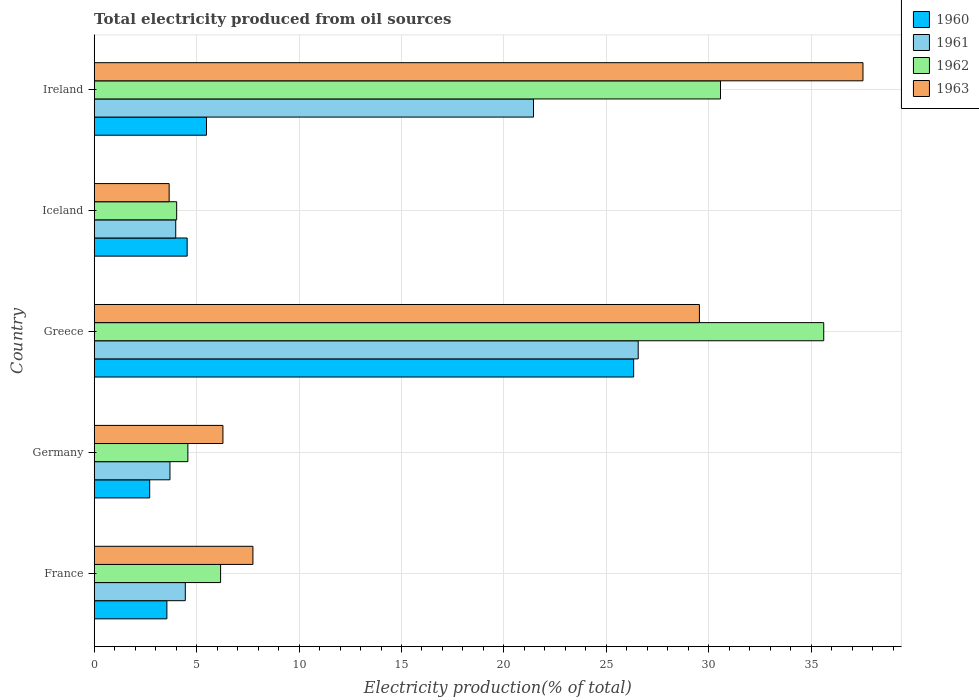How many bars are there on the 4th tick from the top?
Provide a short and direct response. 4. In how many cases, is the number of bars for a given country not equal to the number of legend labels?
Make the answer very short. 0. What is the total electricity produced in 1960 in France?
Provide a succinct answer. 3.55. Across all countries, what is the maximum total electricity produced in 1962?
Provide a succinct answer. 35.61. Across all countries, what is the minimum total electricity produced in 1961?
Offer a terse response. 3.7. In which country was the total electricity produced in 1962 minimum?
Ensure brevity in your answer.  Iceland. What is the total total electricity produced in 1963 in the graph?
Offer a very short reply. 84.76. What is the difference between the total electricity produced in 1962 in Germany and that in Ireland?
Your answer should be compact. -26. What is the difference between the total electricity produced in 1961 in Ireland and the total electricity produced in 1960 in Germany?
Offer a very short reply. 18.73. What is the average total electricity produced in 1963 per country?
Your response must be concise. 16.95. What is the difference between the total electricity produced in 1963 and total electricity produced in 1962 in Ireland?
Provide a succinct answer. 6.95. In how many countries, is the total electricity produced in 1962 greater than 2 %?
Provide a short and direct response. 5. What is the ratio of the total electricity produced in 1962 in France to that in Greece?
Your answer should be very brief. 0.17. Is the total electricity produced in 1960 in Iceland less than that in Ireland?
Keep it short and to the point. Yes. Is the difference between the total electricity produced in 1963 in Greece and Ireland greater than the difference between the total electricity produced in 1962 in Greece and Ireland?
Offer a very short reply. No. What is the difference between the highest and the second highest total electricity produced in 1961?
Your answer should be compact. 5.11. What is the difference between the highest and the lowest total electricity produced in 1963?
Offer a terse response. 33.87. In how many countries, is the total electricity produced in 1963 greater than the average total electricity produced in 1963 taken over all countries?
Keep it short and to the point. 2. Is it the case that in every country, the sum of the total electricity produced in 1960 and total electricity produced in 1962 is greater than the sum of total electricity produced in 1961 and total electricity produced in 1963?
Your answer should be very brief. No. What does the 1st bar from the top in Germany represents?
Give a very brief answer. 1963. Is it the case that in every country, the sum of the total electricity produced in 1963 and total electricity produced in 1960 is greater than the total electricity produced in 1961?
Offer a very short reply. Yes. How many bars are there?
Your response must be concise. 20. What is the difference between two consecutive major ticks on the X-axis?
Your answer should be very brief. 5. Are the values on the major ticks of X-axis written in scientific E-notation?
Your answer should be very brief. No. Does the graph contain any zero values?
Offer a very short reply. No. Does the graph contain grids?
Make the answer very short. Yes. Where does the legend appear in the graph?
Your answer should be compact. Top right. How many legend labels are there?
Offer a very short reply. 4. How are the legend labels stacked?
Your answer should be compact. Vertical. What is the title of the graph?
Your answer should be very brief. Total electricity produced from oil sources. What is the label or title of the Y-axis?
Provide a succinct answer. Country. What is the Electricity production(% of total) of 1960 in France?
Your answer should be very brief. 3.55. What is the Electricity production(% of total) of 1961 in France?
Keep it short and to the point. 4.45. What is the Electricity production(% of total) of 1962 in France?
Your response must be concise. 6.17. What is the Electricity production(% of total) of 1963 in France?
Keep it short and to the point. 7.75. What is the Electricity production(% of total) of 1960 in Germany?
Give a very brief answer. 2.71. What is the Electricity production(% of total) in 1961 in Germany?
Keep it short and to the point. 3.7. What is the Electricity production(% of total) in 1962 in Germany?
Your response must be concise. 4.57. What is the Electricity production(% of total) of 1963 in Germany?
Make the answer very short. 6.28. What is the Electricity production(% of total) of 1960 in Greece?
Your response must be concise. 26.33. What is the Electricity production(% of total) in 1961 in Greece?
Ensure brevity in your answer.  26.55. What is the Electricity production(% of total) of 1962 in Greece?
Make the answer very short. 35.61. What is the Electricity production(% of total) in 1963 in Greece?
Provide a succinct answer. 29.54. What is the Electricity production(% of total) of 1960 in Iceland?
Your answer should be very brief. 4.54. What is the Electricity production(% of total) in 1961 in Iceland?
Your answer should be compact. 3.98. What is the Electricity production(% of total) of 1962 in Iceland?
Your answer should be very brief. 4.03. What is the Electricity production(% of total) of 1963 in Iceland?
Your answer should be compact. 3.66. What is the Electricity production(% of total) of 1960 in Ireland?
Your answer should be compact. 5.48. What is the Electricity production(% of total) in 1961 in Ireland?
Give a very brief answer. 21.44. What is the Electricity production(% of total) of 1962 in Ireland?
Your response must be concise. 30.57. What is the Electricity production(% of total) of 1963 in Ireland?
Provide a short and direct response. 37.53. Across all countries, what is the maximum Electricity production(% of total) in 1960?
Your answer should be very brief. 26.33. Across all countries, what is the maximum Electricity production(% of total) in 1961?
Your response must be concise. 26.55. Across all countries, what is the maximum Electricity production(% of total) in 1962?
Provide a short and direct response. 35.61. Across all countries, what is the maximum Electricity production(% of total) in 1963?
Your answer should be very brief. 37.53. Across all countries, what is the minimum Electricity production(% of total) in 1960?
Provide a short and direct response. 2.71. Across all countries, what is the minimum Electricity production(% of total) of 1961?
Provide a short and direct response. 3.7. Across all countries, what is the minimum Electricity production(% of total) of 1962?
Your answer should be compact. 4.03. Across all countries, what is the minimum Electricity production(% of total) in 1963?
Your answer should be very brief. 3.66. What is the total Electricity production(% of total) of 1960 in the graph?
Provide a short and direct response. 42.61. What is the total Electricity production(% of total) of 1961 in the graph?
Keep it short and to the point. 60.12. What is the total Electricity production(% of total) of 1962 in the graph?
Offer a terse response. 80.95. What is the total Electricity production(% of total) of 1963 in the graph?
Offer a terse response. 84.76. What is the difference between the Electricity production(% of total) in 1960 in France and that in Germany?
Provide a short and direct response. 0.84. What is the difference between the Electricity production(% of total) of 1961 in France and that in Germany?
Give a very brief answer. 0.75. What is the difference between the Electricity production(% of total) in 1962 in France and that in Germany?
Your answer should be compact. 1.6. What is the difference between the Electricity production(% of total) in 1963 in France and that in Germany?
Your response must be concise. 1.46. What is the difference between the Electricity production(% of total) of 1960 in France and that in Greece?
Ensure brevity in your answer.  -22.78. What is the difference between the Electricity production(% of total) in 1961 in France and that in Greece?
Your response must be concise. -22.11. What is the difference between the Electricity production(% of total) in 1962 in France and that in Greece?
Offer a very short reply. -29.44. What is the difference between the Electricity production(% of total) of 1963 in France and that in Greece?
Make the answer very short. -21.79. What is the difference between the Electricity production(% of total) in 1960 in France and that in Iceland?
Your answer should be compact. -0.99. What is the difference between the Electricity production(% of total) of 1961 in France and that in Iceland?
Ensure brevity in your answer.  0.47. What is the difference between the Electricity production(% of total) of 1962 in France and that in Iceland?
Ensure brevity in your answer.  2.14. What is the difference between the Electricity production(% of total) in 1963 in France and that in Iceland?
Provide a short and direct response. 4.09. What is the difference between the Electricity production(% of total) in 1960 in France and that in Ireland?
Your answer should be very brief. -1.93. What is the difference between the Electricity production(% of total) of 1961 in France and that in Ireland?
Give a very brief answer. -17. What is the difference between the Electricity production(% of total) of 1962 in France and that in Ireland?
Make the answer very short. -24.4. What is the difference between the Electricity production(% of total) in 1963 in France and that in Ireland?
Your answer should be very brief. -29.78. What is the difference between the Electricity production(% of total) in 1960 in Germany and that in Greece?
Your response must be concise. -23.62. What is the difference between the Electricity production(% of total) of 1961 in Germany and that in Greece?
Your response must be concise. -22.86. What is the difference between the Electricity production(% of total) in 1962 in Germany and that in Greece?
Your answer should be very brief. -31.04. What is the difference between the Electricity production(% of total) in 1963 in Germany and that in Greece?
Offer a very short reply. -23.26. What is the difference between the Electricity production(% of total) in 1960 in Germany and that in Iceland?
Give a very brief answer. -1.83. What is the difference between the Electricity production(% of total) in 1961 in Germany and that in Iceland?
Make the answer very short. -0.28. What is the difference between the Electricity production(% of total) of 1962 in Germany and that in Iceland?
Provide a short and direct response. 0.55. What is the difference between the Electricity production(% of total) in 1963 in Germany and that in Iceland?
Make the answer very short. 2.63. What is the difference between the Electricity production(% of total) of 1960 in Germany and that in Ireland?
Give a very brief answer. -2.77. What is the difference between the Electricity production(% of total) in 1961 in Germany and that in Ireland?
Your response must be concise. -17.75. What is the difference between the Electricity production(% of total) in 1962 in Germany and that in Ireland?
Ensure brevity in your answer.  -26. What is the difference between the Electricity production(% of total) of 1963 in Germany and that in Ireland?
Your response must be concise. -31.24. What is the difference between the Electricity production(% of total) in 1960 in Greece and that in Iceland?
Make the answer very short. 21.79. What is the difference between the Electricity production(% of total) of 1961 in Greece and that in Iceland?
Provide a short and direct response. 22.57. What is the difference between the Electricity production(% of total) in 1962 in Greece and that in Iceland?
Your response must be concise. 31.58. What is the difference between the Electricity production(% of total) of 1963 in Greece and that in Iceland?
Your answer should be compact. 25.88. What is the difference between the Electricity production(% of total) of 1960 in Greece and that in Ireland?
Offer a terse response. 20.85. What is the difference between the Electricity production(% of total) in 1961 in Greece and that in Ireland?
Your answer should be very brief. 5.11. What is the difference between the Electricity production(% of total) of 1962 in Greece and that in Ireland?
Give a very brief answer. 5.04. What is the difference between the Electricity production(% of total) in 1963 in Greece and that in Ireland?
Offer a very short reply. -7.99. What is the difference between the Electricity production(% of total) of 1960 in Iceland and that in Ireland?
Your answer should be compact. -0.94. What is the difference between the Electricity production(% of total) of 1961 in Iceland and that in Ireland?
Your response must be concise. -17.46. What is the difference between the Electricity production(% of total) in 1962 in Iceland and that in Ireland?
Offer a very short reply. -26.55. What is the difference between the Electricity production(% of total) of 1963 in Iceland and that in Ireland?
Your answer should be very brief. -33.87. What is the difference between the Electricity production(% of total) in 1960 in France and the Electricity production(% of total) in 1961 in Germany?
Offer a terse response. -0.15. What is the difference between the Electricity production(% of total) of 1960 in France and the Electricity production(% of total) of 1962 in Germany?
Provide a short and direct response. -1.02. What is the difference between the Electricity production(% of total) of 1960 in France and the Electricity production(% of total) of 1963 in Germany?
Provide a short and direct response. -2.74. What is the difference between the Electricity production(% of total) in 1961 in France and the Electricity production(% of total) in 1962 in Germany?
Your answer should be very brief. -0.13. What is the difference between the Electricity production(% of total) in 1961 in France and the Electricity production(% of total) in 1963 in Germany?
Make the answer very short. -1.84. What is the difference between the Electricity production(% of total) in 1962 in France and the Electricity production(% of total) in 1963 in Germany?
Keep it short and to the point. -0.11. What is the difference between the Electricity production(% of total) in 1960 in France and the Electricity production(% of total) in 1961 in Greece?
Provide a succinct answer. -23.01. What is the difference between the Electricity production(% of total) of 1960 in France and the Electricity production(% of total) of 1962 in Greece?
Offer a very short reply. -32.06. What is the difference between the Electricity production(% of total) of 1960 in France and the Electricity production(% of total) of 1963 in Greece?
Provide a short and direct response. -25.99. What is the difference between the Electricity production(% of total) in 1961 in France and the Electricity production(% of total) in 1962 in Greece?
Provide a succinct answer. -31.16. What is the difference between the Electricity production(% of total) in 1961 in France and the Electricity production(% of total) in 1963 in Greece?
Your answer should be very brief. -25.09. What is the difference between the Electricity production(% of total) in 1962 in France and the Electricity production(% of total) in 1963 in Greece?
Offer a terse response. -23.37. What is the difference between the Electricity production(% of total) of 1960 in France and the Electricity production(% of total) of 1961 in Iceland?
Make the answer very short. -0.43. What is the difference between the Electricity production(% of total) in 1960 in France and the Electricity production(% of total) in 1962 in Iceland?
Give a very brief answer. -0.48. What is the difference between the Electricity production(% of total) in 1960 in France and the Electricity production(% of total) in 1963 in Iceland?
Provide a succinct answer. -0.11. What is the difference between the Electricity production(% of total) in 1961 in France and the Electricity production(% of total) in 1962 in Iceland?
Provide a short and direct response. 0.42. What is the difference between the Electricity production(% of total) in 1961 in France and the Electricity production(% of total) in 1963 in Iceland?
Ensure brevity in your answer.  0.79. What is the difference between the Electricity production(% of total) in 1962 in France and the Electricity production(% of total) in 1963 in Iceland?
Keep it short and to the point. 2.51. What is the difference between the Electricity production(% of total) of 1960 in France and the Electricity production(% of total) of 1961 in Ireland?
Provide a succinct answer. -17.9. What is the difference between the Electricity production(% of total) of 1960 in France and the Electricity production(% of total) of 1962 in Ireland?
Your answer should be compact. -27.02. What is the difference between the Electricity production(% of total) in 1960 in France and the Electricity production(% of total) in 1963 in Ireland?
Offer a very short reply. -33.98. What is the difference between the Electricity production(% of total) of 1961 in France and the Electricity production(% of total) of 1962 in Ireland?
Offer a very short reply. -26.12. What is the difference between the Electricity production(% of total) in 1961 in France and the Electricity production(% of total) in 1963 in Ireland?
Your answer should be very brief. -33.08. What is the difference between the Electricity production(% of total) in 1962 in France and the Electricity production(% of total) in 1963 in Ireland?
Make the answer very short. -31.36. What is the difference between the Electricity production(% of total) of 1960 in Germany and the Electricity production(% of total) of 1961 in Greece?
Your answer should be compact. -23.85. What is the difference between the Electricity production(% of total) in 1960 in Germany and the Electricity production(% of total) in 1962 in Greece?
Keep it short and to the point. -32.9. What is the difference between the Electricity production(% of total) in 1960 in Germany and the Electricity production(% of total) in 1963 in Greece?
Ensure brevity in your answer.  -26.83. What is the difference between the Electricity production(% of total) of 1961 in Germany and the Electricity production(% of total) of 1962 in Greece?
Make the answer very short. -31.91. What is the difference between the Electricity production(% of total) in 1961 in Germany and the Electricity production(% of total) in 1963 in Greece?
Your answer should be compact. -25.84. What is the difference between the Electricity production(% of total) of 1962 in Germany and the Electricity production(% of total) of 1963 in Greece?
Offer a very short reply. -24.97. What is the difference between the Electricity production(% of total) of 1960 in Germany and the Electricity production(% of total) of 1961 in Iceland?
Provide a short and direct response. -1.27. What is the difference between the Electricity production(% of total) in 1960 in Germany and the Electricity production(% of total) in 1962 in Iceland?
Give a very brief answer. -1.32. What is the difference between the Electricity production(% of total) in 1960 in Germany and the Electricity production(% of total) in 1963 in Iceland?
Make the answer very short. -0.95. What is the difference between the Electricity production(% of total) of 1961 in Germany and the Electricity production(% of total) of 1962 in Iceland?
Your answer should be very brief. -0.33. What is the difference between the Electricity production(% of total) of 1961 in Germany and the Electricity production(% of total) of 1963 in Iceland?
Offer a very short reply. 0.04. What is the difference between the Electricity production(% of total) in 1962 in Germany and the Electricity production(% of total) in 1963 in Iceland?
Your answer should be compact. 0.91. What is the difference between the Electricity production(% of total) of 1960 in Germany and the Electricity production(% of total) of 1961 in Ireland?
Provide a succinct answer. -18.73. What is the difference between the Electricity production(% of total) in 1960 in Germany and the Electricity production(% of total) in 1962 in Ireland?
Your answer should be very brief. -27.86. What is the difference between the Electricity production(% of total) in 1960 in Germany and the Electricity production(% of total) in 1963 in Ireland?
Provide a short and direct response. -34.82. What is the difference between the Electricity production(% of total) of 1961 in Germany and the Electricity production(% of total) of 1962 in Ireland?
Your response must be concise. -26.87. What is the difference between the Electricity production(% of total) of 1961 in Germany and the Electricity production(% of total) of 1963 in Ireland?
Provide a short and direct response. -33.83. What is the difference between the Electricity production(% of total) in 1962 in Germany and the Electricity production(% of total) in 1963 in Ireland?
Your response must be concise. -32.95. What is the difference between the Electricity production(% of total) of 1960 in Greece and the Electricity production(% of total) of 1961 in Iceland?
Ensure brevity in your answer.  22.35. What is the difference between the Electricity production(% of total) in 1960 in Greece and the Electricity production(% of total) in 1962 in Iceland?
Give a very brief answer. 22.31. What is the difference between the Electricity production(% of total) in 1960 in Greece and the Electricity production(% of total) in 1963 in Iceland?
Your response must be concise. 22.67. What is the difference between the Electricity production(% of total) in 1961 in Greece and the Electricity production(% of total) in 1962 in Iceland?
Provide a short and direct response. 22.53. What is the difference between the Electricity production(% of total) of 1961 in Greece and the Electricity production(% of total) of 1963 in Iceland?
Offer a terse response. 22.9. What is the difference between the Electricity production(% of total) in 1962 in Greece and the Electricity production(% of total) in 1963 in Iceland?
Offer a terse response. 31.95. What is the difference between the Electricity production(% of total) of 1960 in Greece and the Electricity production(% of total) of 1961 in Ireland?
Make the answer very short. 4.89. What is the difference between the Electricity production(% of total) of 1960 in Greece and the Electricity production(% of total) of 1962 in Ireland?
Offer a very short reply. -4.24. What is the difference between the Electricity production(% of total) in 1960 in Greece and the Electricity production(% of total) in 1963 in Ireland?
Your answer should be very brief. -11.19. What is the difference between the Electricity production(% of total) of 1961 in Greece and the Electricity production(% of total) of 1962 in Ireland?
Your answer should be very brief. -4.02. What is the difference between the Electricity production(% of total) of 1961 in Greece and the Electricity production(% of total) of 1963 in Ireland?
Your response must be concise. -10.97. What is the difference between the Electricity production(% of total) in 1962 in Greece and the Electricity production(% of total) in 1963 in Ireland?
Your answer should be compact. -1.92. What is the difference between the Electricity production(% of total) in 1960 in Iceland and the Electricity production(% of total) in 1961 in Ireland?
Provide a succinct answer. -16.91. What is the difference between the Electricity production(% of total) in 1960 in Iceland and the Electricity production(% of total) in 1962 in Ireland?
Ensure brevity in your answer.  -26.03. What is the difference between the Electricity production(% of total) in 1960 in Iceland and the Electricity production(% of total) in 1963 in Ireland?
Provide a short and direct response. -32.99. What is the difference between the Electricity production(% of total) of 1961 in Iceland and the Electricity production(% of total) of 1962 in Ireland?
Your response must be concise. -26.59. What is the difference between the Electricity production(% of total) in 1961 in Iceland and the Electricity production(% of total) in 1963 in Ireland?
Provide a short and direct response. -33.55. What is the difference between the Electricity production(% of total) in 1962 in Iceland and the Electricity production(% of total) in 1963 in Ireland?
Your answer should be very brief. -33.5. What is the average Electricity production(% of total) in 1960 per country?
Offer a terse response. 8.52. What is the average Electricity production(% of total) in 1961 per country?
Your answer should be compact. 12.02. What is the average Electricity production(% of total) in 1962 per country?
Your answer should be very brief. 16.19. What is the average Electricity production(% of total) of 1963 per country?
Your answer should be compact. 16.95. What is the difference between the Electricity production(% of total) in 1960 and Electricity production(% of total) in 1961 in France?
Your response must be concise. -0.9. What is the difference between the Electricity production(% of total) in 1960 and Electricity production(% of total) in 1962 in France?
Offer a very short reply. -2.62. What is the difference between the Electricity production(% of total) in 1960 and Electricity production(% of total) in 1963 in France?
Your answer should be very brief. -4.2. What is the difference between the Electricity production(% of total) of 1961 and Electricity production(% of total) of 1962 in France?
Offer a very short reply. -1.72. What is the difference between the Electricity production(% of total) in 1961 and Electricity production(% of total) in 1963 in France?
Your response must be concise. -3.3. What is the difference between the Electricity production(% of total) in 1962 and Electricity production(% of total) in 1963 in France?
Keep it short and to the point. -1.58. What is the difference between the Electricity production(% of total) of 1960 and Electricity production(% of total) of 1961 in Germany?
Ensure brevity in your answer.  -0.99. What is the difference between the Electricity production(% of total) of 1960 and Electricity production(% of total) of 1962 in Germany?
Make the answer very short. -1.86. What is the difference between the Electricity production(% of total) of 1960 and Electricity production(% of total) of 1963 in Germany?
Your answer should be very brief. -3.58. What is the difference between the Electricity production(% of total) of 1961 and Electricity production(% of total) of 1962 in Germany?
Your response must be concise. -0.87. What is the difference between the Electricity production(% of total) in 1961 and Electricity production(% of total) in 1963 in Germany?
Ensure brevity in your answer.  -2.59. What is the difference between the Electricity production(% of total) of 1962 and Electricity production(% of total) of 1963 in Germany?
Ensure brevity in your answer.  -1.71. What is the difference between the Electricity production(% of total) of 1960 and Electricity production(% of total) of 1961 in Greece?
Your answer should be very brief. -0.22. What is the difference between the Electricity production(% of total) in 1960 and Electricity production(% of total) in 1962 in Greece?
Your response must be concise. -9.28. What is the difference between the Electricity production(% of total) in 1960 and Electricity production(% of total) in 1963 in Greece?
Provide a succinct answer. -3.21. What is the difference between the Electricity production(% of total) of 1961 and Electricity production(% of total) of 1962 in Greece?
Give a very brief answer. -9.06. What is the difference between the Electricity production(% of total) in 1961 and Electricity production(% of total) in 1963 in Greece?
Your response must be concise. -2.99. What is the difference between the Electricity production(% of total) in 1962 and Electricity production(% of total) in 1963 in Greece?
Ensure brevity in your answer.  6.07. What is the difference between the Electricity production(% of total) of 1960 and Electricity production(% of total) of 1961 in Iceland?
Your answer should be very brief. 0.56. What is the difference between the Electricity production(% of total) in 1960 and Electricity production(% of total) in 1962 in Iceland?
Provide a succinct answer. 0.51. What is the difference between the Electricity production(% of total) of 1960 and Electricity production(% of total) of 1963 in Iceland?
Offer a terse response. 0.88. What is the difference between the Electricity production(% of total) in 1961 and Electricity production(% of total) in 1962 in Iceland?
Make the answer very short. -0.05. What is the difference between the Electricity production(% of total) in 1961 and Electricity production(% of total) in 1963 in Iceland?
Provide a succinct answer. 0.32. What is the difference between the Electricity production(% of total) in 1962 and Electricity production(% of total) in 1963 in Iceland?
Offer a very short reply. 0.37. What is the difference between the Electricity production(% of total) of 1960 and Electricity production(% of total) of 1961 in Ireland?
Your answer should be very brief. -15.96. What is the difference between the Electricity production(% of total) of 1960 and Electricity production(% of total) of 1962 in Ireland?
Give a very brief answer. -25.09. What is the difference between the Electricity production(% of total) in 1960 and Electricity production(% of total) in 1963 in Ireland?
Provide a short and direct response. -32.04. What is the difference between the Electricity production(% of total) in 1961 and Electricity production(% of total) in 1962 in Ireland?
Make the answer very short. -9.13. What is the difference between the Electricity production(% of total) in 1961 and Electricity production(% of total) in 1963 in Ireland?
Offer a terse response. -16.08. What is the difference between the Electricity production(% of total) in 1962 and Electricity production(% of total) in 1963 in Ireland?
Ensure brevity in your answer.  -6.95. What is the ratio of the Electricity production(% of total) of 1960 in France to that in Germany?
Make the answer very short. 1.31. What is the ratio of the Electricity production(% of total) in 1961 in France to that in Germany?
Provide a short and direct response. 1.2. What is the ratio of the Electricity production(% of total) of 1962 in France to that in Germany?
Provide a succinct answer. 1.35. What is the ratio of the Electricity production(% of total) of 1963 in France to that in Germany?
Offer a very short reply. 1.23. What is the ratio of the Electricity production(% of total) of 1960 in France to that in Greece?
Your response must be concise. 0.13. What is the ratio of the Electricity production(% of total) in 1961 in France to that in Greece?
Provide a short and direct response. 0.17. What is the ratio of the Electricity production(% of total) of 1962 in France to that in Greece?
Your response must be concise. 0.17. What is the ratio of the Electricity production(% of total) of 1963 in France to that in Greece?
Make the answer very short. 0.26. What is the ratio of the Electricity production(% of total) in 1960 in France to that in Iceland?
Provide a succinct answer. 0.78. What is the ratio of the Electricity production(% of total) of 1961 in France to that in Iceland?
Your response must be concise. 1.12. What is the ratio of the Electricity production(% of total) in 1962 in France to that in Iceland?
Your answer should be compact. 1.53. What is the ratio of the Electricity production(% of total) of 1963 in France to that in Iceland?
Keep it short and to the point. 2.12. What is the ratio of the Electricity production(% of total) in 1960 in France to that in Ireland?
Your response must be concise. 0.65. What is the ratio of the Electricity production(% of total) in 1961 in France to that in Ireland?
Give a very brief answer. 0.21. What is the ratio of the Electricity production(% of total) in 1962 in France to that in Ireland?
Make the answer very short. 0.2. What is the ratio of the Electricity production(% of total) of 1963 in France to that in Ireland?
Give a very brief answer. 0.21. What is the ratio of the Electricity production(% of total) in 1960 in Germany to that in Greece?
Provide a short and direct response. 0.1. What is the ratio of the Electricity production(% of total) in 1961 in Germany to that in Greece?
Offer a very short reply. 0.14. What is the ratio of the Electricity production(% of total) in 1962 in Germany to that in Greece?
Your answer should be compact. 0.13. What is the ratio of the Electricity production(% of total) in 1963 in Germany to that in Greece?
Your answer should be compact. 0.21. What is the ratio of the Electricity production(% of total) of 1960 in Germany to that in Iceland?
Give a very brief answer. 0.6. What is the ratio of the Electricity production(% of total) in 1961 in Germany to that in Iceland?
Offer a terse response. 0.93. What is the ratio of the Electricity production(% of total) in 1962 in Germany to that in Iceland?
Provide a short and direct response. 1.14. What is the ratio of the Electricity production(% of total) of 1963 in Germany to that in Iceland?
Your answer should be very brief. 1.72. What is the ratio of the Electricity production(% of total) of 1960 in Germany to that in Ireland?
Keep it short and to the point. 0.49. What is the ratio of the Electricity production(% of total) of 1961 in Germany to that in Ireland?
Provide a short and direct response. 0.17. What is the ratio of the Electricity production(% of total) of 1962 in Germany to that in Ireland?
Your response must be concise. 0.15. What is the ratio of the Electricity production(% of total) of 1963 in Germany to that in Ireland?
Your response must be concise. 0.17. What is the ratio of the Electricity production(% of total) in 1960 in Greece to that in Iceland?
Offer a terse response. 5.8. What is the ratio of the Electricity production(% of total) in 1961 in Greece to that in Iceland?
Provide a short and direct response. 6.67. What is the ratio of the Electricity production(% of total) of 1962 in Greece to that in Iceland?
Offer a terse response. 8.85. What is the ratio of the Electricity production(% of total) of 1963 in Greece to that in Iceland?
Offer a very short reply. 8.07. What is the ratio of the Electricity production(% of total) of 1960 in Greece to that in Ireland?
Keep it short and to the point. 4.8. What is the ratio of the Electricity production(% of total) of 1961 in Greece to that in Ireland?
Your answer should be compact. 1.24. What is the ratio of the Electricity production(% of total) in 1962 in Greece to that in Ireland?
Provide a short and direct response. 1.16. What is the ratio of the Electricity production(% of total) in 1963 in Greece to that in Ireland?
Keep it short and to the point. 0.79. What is the ratio of the Electricity production(% of total) of 1960 in Iceland to that in Ireland?
Offer a very short reply. 0.83. What is the ratio of the Electricity production(% of total) of 1961 in Iceland to that in Ireland?
Offer a very short reply. 0.19. What is the ratio of the Electricity production(% of total) of 1962 in Iceland to that in Ireland?
Provide a succinct answer. 0.13. What is the ratio of the Electricity production(% of total) in 1963 in Iceland to that in Ireland?
Your answer should be very brief. 0.1. What is the difference between the highest and the second highest Electricity production(% of total) of 1960?
Your response must be concise. 20.85. What is the difference between the highest and the second highest Electricity production(% of total) in 1961?
Make the answer very short. 5.11. What is the difference between the highest and the second highest Electricity production(% of total) of 1962?
Keep it short and to the point. 5.04. What is the difference between the highest and the second highest Electricity production(% of total) of 1963?
Keep it short and to the point. 7.99. What is the difference between the highest and the lowest Electricity production(% of total) in 1960?
Make the answer very short. 23.62. What is the difference between the highest and the lowest Electricity production(% of total) in 1961?
Make the answer very short. 22.86. What is the difference between the highest and the lowest Electricity production(% of total) of 1962?
Provide a short and direct response. 31.58. What is the difference between the highest and the lowest Electricity production(% of total) of 1963?
Give a very brief answer. 33.87. 